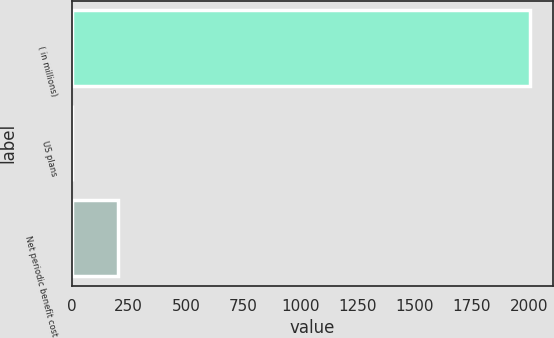Convert chart to OTSL. <chart><loc_0><loc_0><loc_500><loc_500><bar_chart><fcel>( in millions)<fcel>US plans<fcel>Net periodic benefit cost<nl><fcel>2006<fcel>1.9<fcel>202.31<nl></chart> 